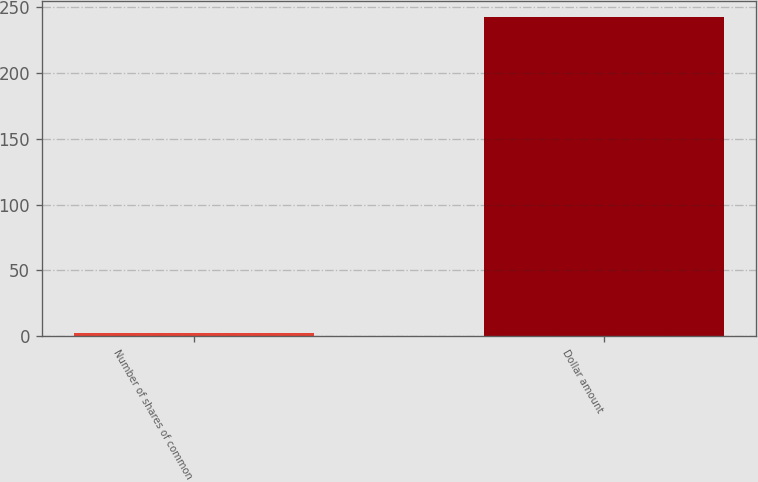Convert chart to OTSL. <chart><loc_0><loc_0><loc_500><loc_500><bar_chart><fcel>Number of shares of common<fcel>Dollar amount<nl><fcel>2.6<fcel>242.7<nl></chart> 